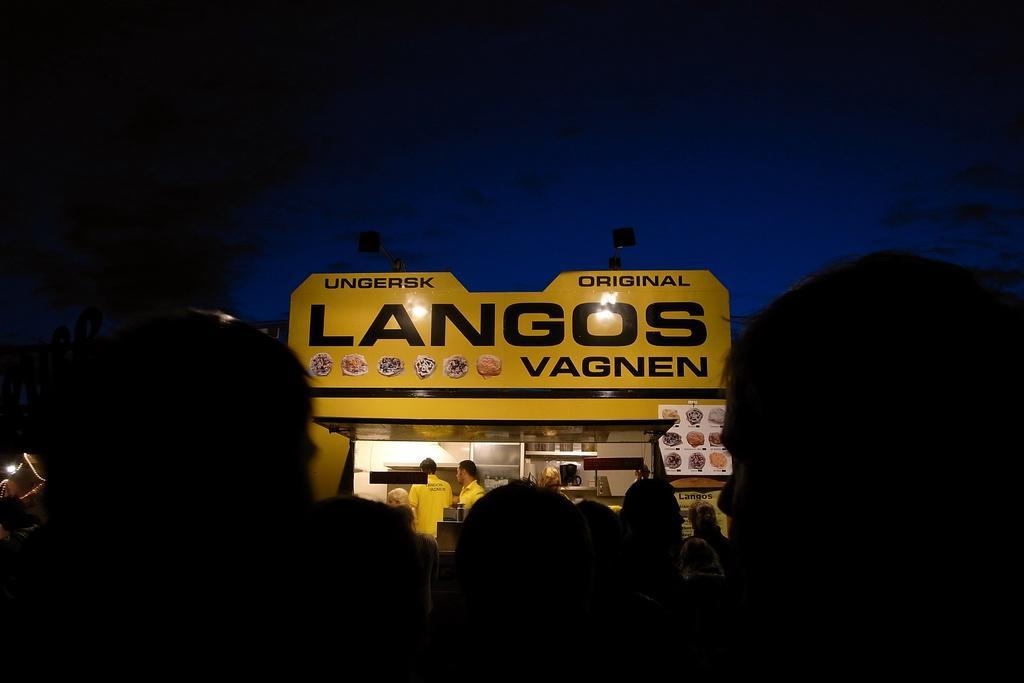Please provide a concise description of this image. In this picture we can see a group of people and in front of them we can see three people, posters, lights and some objects and in the background we can see the sky. 